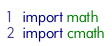Convert code to text. <code><loc_0><loc_0><loc_500><loc_500><_Python_>import math
import cmath

</code> 